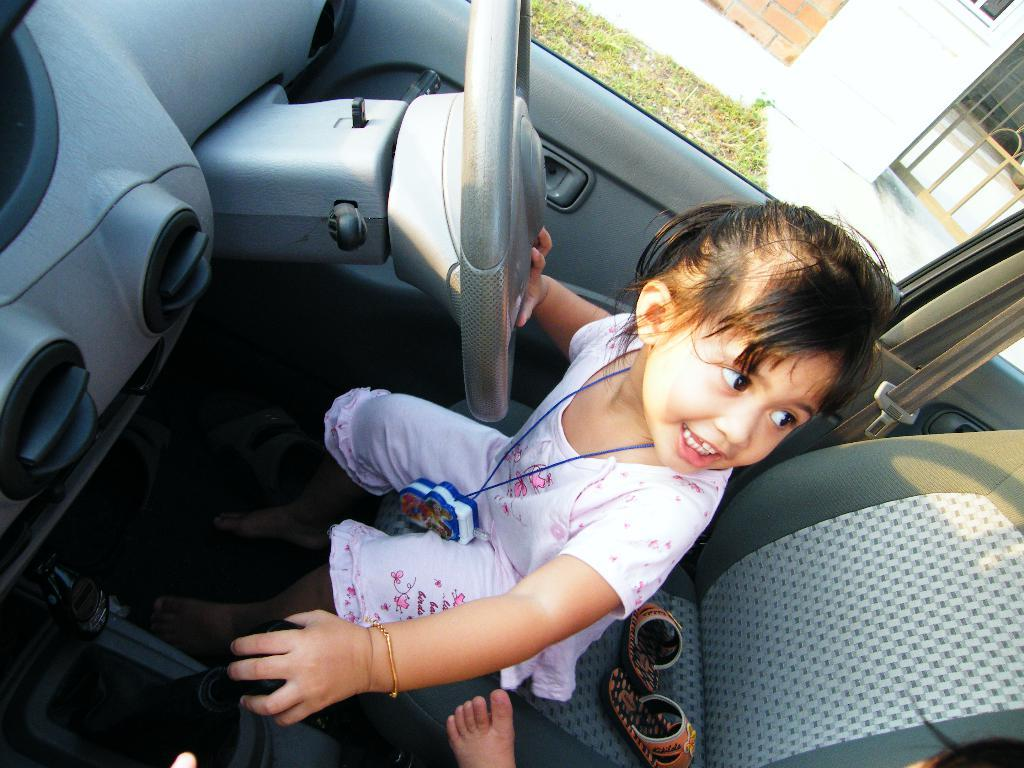What is the girl doing in the image? The girl is sitting on a seat inside a car. What can be seen outside the car? There is grass visible outside the car. Where is the basket of waste located in the image? There is no basket of waste present in the image. How does the car move in the image? The car does not move in the image; it is stationary. 